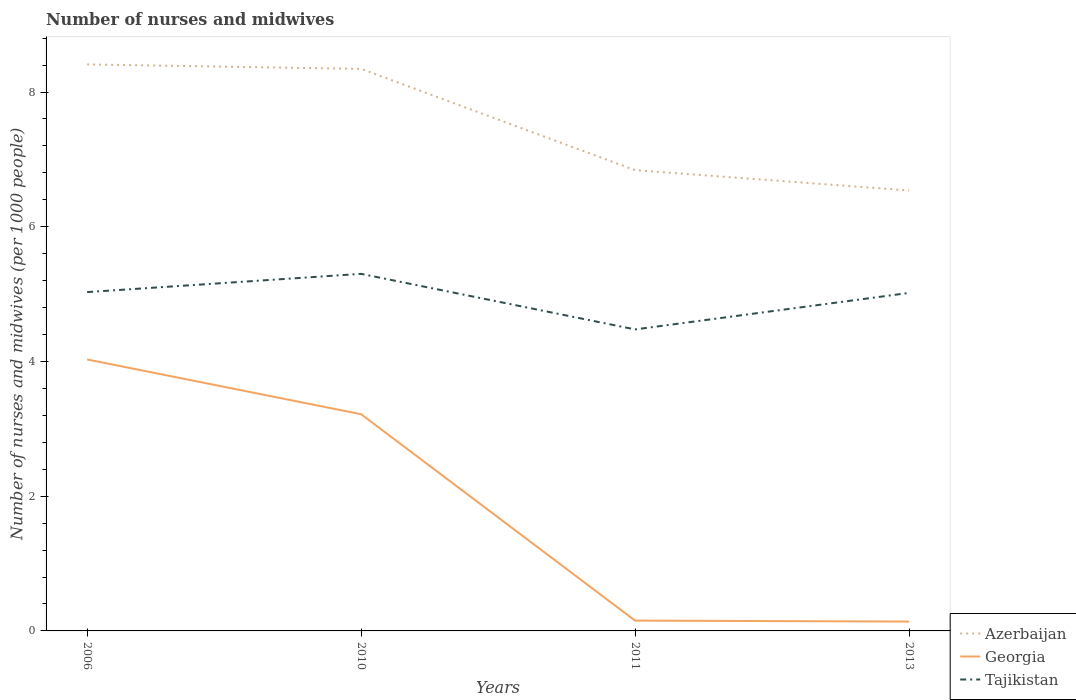Does the line corresponding to Azerbaijan intersect with the line corresponding to Tajikistan?
Provide a short and direct response. No. Is the number of lines equal to the number of legend labels?
Give a very brief answer. Yes. Across all years, what is the maximum number of nurses and midwives in in Georgia?
Offer a terse response. 0.14. What is the total number of nurses and midwives in in Georgia in the graph?
Offer a terse response. 0.01. What is the difference between the highest and the second highest number of nurses and midwives in in Azerbaijan?
Keep it short and to the point. 1.87. What is the difference between the highest and the lowest number of nurses and midwives in in Georgia?
Offer a very short reply. 2. Are the values on the major ticks of Y-axis written in scientific E-notation?
Make the answer very short. No. Does the graph contain any zero values?
Provide a succinct answer. No. Does the graph contain grids?
Your answer should be very brief. No. Where does the legend appear in the graph?
Offer a very short reply. Bottom right. What is the title of the graph?
Make the answer very short. Number of nurses and midwives. What is the label or title of the Y-axis?
Ensure brevity in your answer.  Number of nurses and midwives (per 1000 people). What is the Number of nurses and midwives (per 1000 people) in Azerbaijan in 2006?
Your answer should be compact. 8.41. What is the Number of nurses and midwives (per 1000 people) in Georgia in 2006?
Your response must be concise. 4.03. What is the Number of nurses and midwives (per 1000 people) of Tajikistan in 2006?
Your answer should be compact. 5.03. What is the Number of nurses and midwives (per 1000 people) in Azerbaijan in 2010?
Provide a short and direct response. 8.34. What is the Number of nurses and midwives (per 1000 people) of Georgia in 2010?
Your answer should be compact. 3.22. What is the Number of nurses and midwives (per 1000 people) in Tajikistan in 2010?
Ensure brevity in your answer.  5.3. What is the Number of nurses and midwives (per 1000 people) in Azerbaijan in 2011?
Your answer should be very brief. 6.84. What is the Number of nurses and midwives (per 1000 people) in Georgia in 2011?
Your answer should be very brief. 0.15. What is the Number of nurses and midwives (per 1000 people) of Tajikistan in 2011?
Keep it short and to the point. 4.48. What is the Number of nurses and midwives (per 1000 people) of Azerbaijan in 2013?
Make the answer very short. 6.54. What is the Number of nurses and midwives (per 1000 people) in Georgia in 2013?
Provide a succinct answer. 0.14. What is the Number of nurses and midwives (per 1000 people) in Tajikistan in 2013?
Make the answer very short. 5.02. Across all years, what is the maximum Number of nurses and midwives (per 1000 people) in Azerbaijan?
Offer a terse response. 8.41. Across all years, what is the maximum Number of nurses and midwives (per 1000 people) of Georgia?
Keep it short and to the point. 4.03. Across all years, what is the maximum Number of nurses and midwives (per 1000 people) of Tajikistan?
Your answer should be very brief. 5.3. Across all years, what is the minimum Number of nurses and midwives (per 1000 people) in Azerbaijan?
Your answer should be very brief. 6.54. Across all years, what is the minimum Number of nurses and midwives (per 1000 people) of Georgia?
Offer a very short reply. 0.14. Across all years, what is the minimum Number of nurses and midwives (per 1000 people) in Tajikistan?
Provide a succinct answer. 4.48. What is the total Number of nurses and midwives (per 1000 people) in Azerbaijan in the graph?
Make the answer very short. 30.13. What is the total Number of nurses and midwives (per 1000 people) in Georgia in the graph?
Your answer should be compact. 7.54. What is the total Number of nurses and midwives (per 1000 people) of Tajikistan in the graph?
Offer a terse response. 19.82. What is the difference between the Number of nurses and midwives (per 1000 people) in Azerbaijan in 2006 and that in 2010?
Ensure brevity in your answer.  0.07. What is the difference between the Number of nurses and midwives (per 1000 people) in Georgia in 2006 and that in 2010?
Offer a very short reply. 0.81. What is the difference between the Number of nurses and midwives (per 1000 people) of Tajikistan in 2006 and that in 2010?
Keep it short and to the point. -0.27. What is the difference between the Number of nurses and midwives (per 1000 people) in Azerbaijan in 2006 and that in 2011?
Make the answer very short. 1.57. What is the difference between the Number of nurses and midwives (per 1000 people) in Georgia in 2006 and that in 2011?
Provide a succinct answer. 3.88. What is the difference between the Number of nurses and midwives (per 1000 people) in Tajikistan in 2006 and that in 2011?
Make the answer very short. 0.55. What is the difference between the Number of nurses and midwives (per 1000 people) of Azerbaijan in 2006 and that in 2013?
Offer a terse response. 1.87. What is the difference between the Number of nurses and midwives (per 1000 people) in Georgia in 2006 and that in 2013?
Keep it short and to the point. 3.89. What is the difference between the Number of nurses and midwives (per 1000 people) in Tajikistan in 2006 and that in 2013?
Offer a very short reply. 0.01. What is the difference between the Number of nurses and midwives (per 1000 people) of Azerbaijan in 2010 and that in 2011?
Offer a terse response. 1.5. What is the difference between the Number of nurses and midwives (per 1000 people) in Georgia in 2010 and that in 2011?
Keep it short and to the point. 3.06. What is the difference between the Number of nurses and midwives (per 1000 people) in Tajikistan in 2010 and that in 2011?
Keep it short and to the point. 0.82. What is the difference between the Number of nurses and midwives (per 1000 people) in Azerbaijan in 2010 and that in 2013?
Give a very brief answer. 1.8. What is the difference between the Number of nurses and midwives (per 1000 people) of Georgia in 2010 and that in 2013?
Make the answer very short. 3.08. What is the difference between the Number of nurses and midwives (per 1000 people) in Tajikistan in 2010 and that in 2013?
Your response must be concise. 0.28. What is the difference between the Number of nurses and midwives (per 1000 people) in Azerbaijan in 2011 and that in 2013?
Keep it short and to the point. 0.3. What is the difference between the Number of nurses and midwives (per 1000 people) of Georgia in 2011 and that in 2013?
Offer a terse response. 0.01. What is the difference between the Number of nurses and midwives (per 1000 people) of Tajikistan in 2011 and that in 2013?
Provide a succinct answer. -0.54. What is the difference between the Number of nurses and midwives (per 1000 people) of Azerbaijan in 2006 and the Number of nurses and midwives (per 1000 people) of Georgia in 2010?
Provide a short and direct response. 5.19. What is the difference between the Number of nurses and midwives (per 1000 people) of Azerbaijan in 2006 and the Number of nurses and midwives (per 1000 people) of Tajikistan in 2010?
Give a very brief answer. 3.11. What is the difference between the Number of nurses and midwives (per 1000 people) of Georgia in 2006 and the Number of nurses and midwives (per 1000 people) of Tajikistan in 2010?
Ensure brevity in your answer.  -1.27. What is the difference between the Number of nurses and midwives (per 1000 people) in Azerbaijan in 2006 and the Number of nurses and midwives (per 1000 people) in Georgia in 2011?
Provide a short and direct response. 8.26. What is the difference between the Number of nurses and midwives (per 1000 people) in Azerbaijan in 2006 and the Number of nurses and midwives (per 1000 people) in Tajikistan in 2011?
Offer a very short reply. 3.93. What is the difference between the Number of nurses and midwives (per 1000 people) in Georgia in 2006 and the Number of nurses and midwives (per 1000 people) in Tajikistan in 2011?
Your answer should be very brief. -0.45. What is the difference between the Number of nurses and midwives (per 1000 people) in Azerbaijan in 2006 and the Number of nurses and midwives (per 1000 people) in Georgia in 2013?
Make the answer very short. 8.27. What is the difference between the Number of nurses and midwives (per 1000 people) of Azerbaijan in 2006 and the Number of nurses and midwives (per 1000 people) of Tajikistan in 2013?
Your response must be concise. 3.39. What is the difference between the Number of nurses and midwives (per 1000 people) of Georgia in 2006 and the Number of nurses and midwives (per 1000 people) of Tajikistan in 2013?
Provide a succinct answer. -0.99. What is the difference between the Number of nurses and midwives (per 1000 people) in Azerbaijan in 2010 and the Number of nurses and midwives (per 1000 people) in Georgia in 2011?
Offer a terse response. 8.19. What is the difference between the Number of nurses and midwives (per 1000 people) in Azerbaijan in 2010 and the Number of nurses and midwives (per 1000 people) in Tajikistan in 2011?
Offer a terse response. 3.87. What is the difference between the Number of nurses and midwives (per 1000 people) in Georgia in 2010 and the Number of nurses and midwives (per 1000 people) in Tajikistan in 2011?
Your answer should be compact. -1.26. What is the difference between the Number of nurses and midwives (per 1000 people) in Azerbaijan in 2010 and the Number of nurses and midwives (per 1000 people) in Georgia in 2013?
Make the answer very short. 8.21. What is the difference between the Number of nurses and midwives (per 1000 people) of Azerbaijan in 2010 and the Number of nurses and midwives (per 1000 people) of Tajikistan in 2013?
Your response must be concise. 3.33. What is the difference between the Number of nurses and midwives (per 1000 people) of Georgia in 2010 and the Number of nurses and midwives (per 1000 people) of Tajikistan in 2013?
Your response must be concise. -1.8. What is the difference between the Number of nurses and midwives (per 1000 people) of Azerbaijan in 2011 and the Number of nurses and midwives (per 1000 people) of Georgia in 2013?
Ensure brevity in your answer.  6.7. What is the difference between the Number of nurses and midwives (per 1000 people) in Azerbaijan in 2011 and the Number of nurses and midwives (per 1000 people) in Tajikistan in 2013?
Your answer should be compact. 1.82. What is the difference between the Number of nurses and midwives (per 1000 people) of Georgia in 2011 and the Number of nurses and midwives (per 1000 people) of Tajikistan in 2013?
Offer a terse response. -4.87. What is the average Number of nurses and midwives (per 1000 people) of Azerbaijan per year?
Give a very brief answer. 7.53. What is the average Number of nurses and midwives (per 1000 people) of Georgia per year?
Your response must be concise. 1.88. What is the average Number of nurses and midwives (per 1000 people) of Tajikistan per year?
Your answer should be very brief. 4.96. In the year 2006, what is the difference between the Number of nurses and midwives (per 1000 people) of Azerbaijan and Number of nurses and midwives (per 1000 people) of Georgia?
Your answer should be compact. 4.38. In the year 2006, what is the difference between the Number of nurses and midwives (per 1000 people) of Azerbaijan and Number of nurses and midwives (per 1000 people) of Tajikistan?
Keep it short and to the point. 3.38. In the year 2010, what is the difference between the Number of nurses and midwives (per 1000 people) in Azerbaijan and Number of nurses and midwives (per 1000 people) in Georgia?
Make the answer very short. 5.13. In the year 2010, what is the difference between the Number of nurses and midwives (per 1000 people) in Azerbaijan and Number of nurses and midwives (per 1000 people) in Tajikistan?
Keep it short and to the point. 3.04. In the year 2010, what is the difference between the Number of nurses and midwives (per 1000 people) in Georgia and Number of nurses and midwives (per 1000 people) in Tajikistan?
Provide a short and direct response. -2.08. In the year 2011, what is the difference between the Number of nurses and midwives (per 1000 people) of Azerbaijan and Number of nurses and midwives (per 1000 people) of Georgia?
Your answer should be very brief. 6.69. In the year 2011, what is the difference between the Number of nurses and midwives (per 1000 people) of Azerbaijan and Number of nurses and midwives (per 1000 people) of Tajikistan?
Offer a very short reply. 2.36. In the year 2011, what is the difference between the Number of nurses and midwives (per 1000 people) in Georgia and Number of nurses and midwives (per 1000 people) in Tajikistan?
Give a very brief answer. -4.32. In the year 2013, what is the difference between the Number of nurses and midwives (per 1000 people) in Azerbaijan and Number of nurses and midwives (per 1000 people) in Tajikistan?
Give a very brief answer. 1.52. In the year 2013, what is the difference between the Number of nurses and midwives (per 1000 people) in Georgia and Number of nurses and midwives (per 1000 people) in Tajikistan?
Give a very brief answer. -4.88. What is the ratio of the Number of nurses and midwives (per 1000 people) of Azerbaijan in 2006 to that in 2010?
Offer a very short reply. 1.01. What is the ratio of the Number of nurses and midwives (per 1000 people) of Georgia in 2006 to that in 2010?
Your answer should be compact. 1.25. What is the ratio of the Number of nurses and midwives (per 1000 people) in Tajikistan in 2006 to that in 2010?
Your response must be concise. 0.95. What is the ratio of the Number of nurses and midwives (per 1000 people) in Azerbaijan in 2006 to that in 2011?
Your answer should be compact. 1.23. What is the ratio of the Number of nurses and midwives (per 1000 people) in Georgia in 2006 to that in 2011?
Your answer should be very brief. 26.34. What is the ratio of the Number of nurses and midwives (per 1000 people) of Tajikistan in 2006 to that in 2011?
Provide a short and direct response. 1.12. What is the ratio of the Number of nurses and midwives (per 1000 people) of Azerbaijan in 2006 to that in 2013?
Offer a very short reply. 1.29. What is the ratio of the Number of nurses and midwives (per 1000 people) in Georgia in 2006 to that in 2013?
Give a very brief answer. 28.99. What is the ratio of the Number of nurses and midwives (per 1000 people) in Azerbaijan in 2010 to that in 2011?
Give a very brief answer. 1.22. What is the ratio of the Number of nurses and midwives (per 1000 people) in Georgia in 2010 to that in 2011?
Ensure brevity in your answer.  21.03. What is the ratio of the Number of nurses and midwives (per 1000 people) in Tajikistan in 2010 to that in 2011?
Give a very brief answer. 1.18. What is the ratio of the Number of nurses and midwives (per 1000 people) in Azerbaijan in 2010 to that in 2013?
Offer a very short reply. 1.28. What is the ratio of the Number of nurses and midwives (per 1000 people) in Georgia in 2010 to that in 2013?
Provide a short and direct response. 23.14. What is the ratio of the Number of nurses and midwives (per 1000 people) of Tajikistan in 2010 to that in 2013?
Your response must be concise. 1.06. What is the ratio of the Number of nurses and midwives (per 1000 people) of Azerbaijan in 2011 to that in 2013?
Your answer should be very brief. 1.05. What is the ratio of the Number of nurses and midwives (per 1000 people) in Georgia in 2011 to that in 2013?
Your answer should be very brief. 1.1. What is the ratio of the Number of nurses and midwives (per 1000 people) in Tajikistan in 2011 to that in 2013?
Your answer should be very brief. 0.89. What is the difference between the highest and the second highest Number of nurses and midwives (per 1000 people) in Azerbaijan?
Your answer should be compact. 0.07. What is the difference between the highest and the second highest Number of nurses and midwives (per 1000 people) in Georgia?
Provide a short and direct response. 0.81. What is the difference between the highest and the second highest Number of nurses and midwives (per 1000 people) in Tajikistan?
Ensure brevity in your answer.  0.27. What is the difference between the highest and the lowest Number of nurses and midwives (per 1000 people) in Azerbaijan?
Keep it short and to the point. 1.87. What is the difference between the highest and the lowest Number of nurses and midwives (per 1000 people) of Georgia?
Offer a very short reply. 3.89. What is the difference between the highest and the lowest Number of nurses and midwives (per 1000 people) of Tajikistan?
Your answer should be very brief. 0.82. 